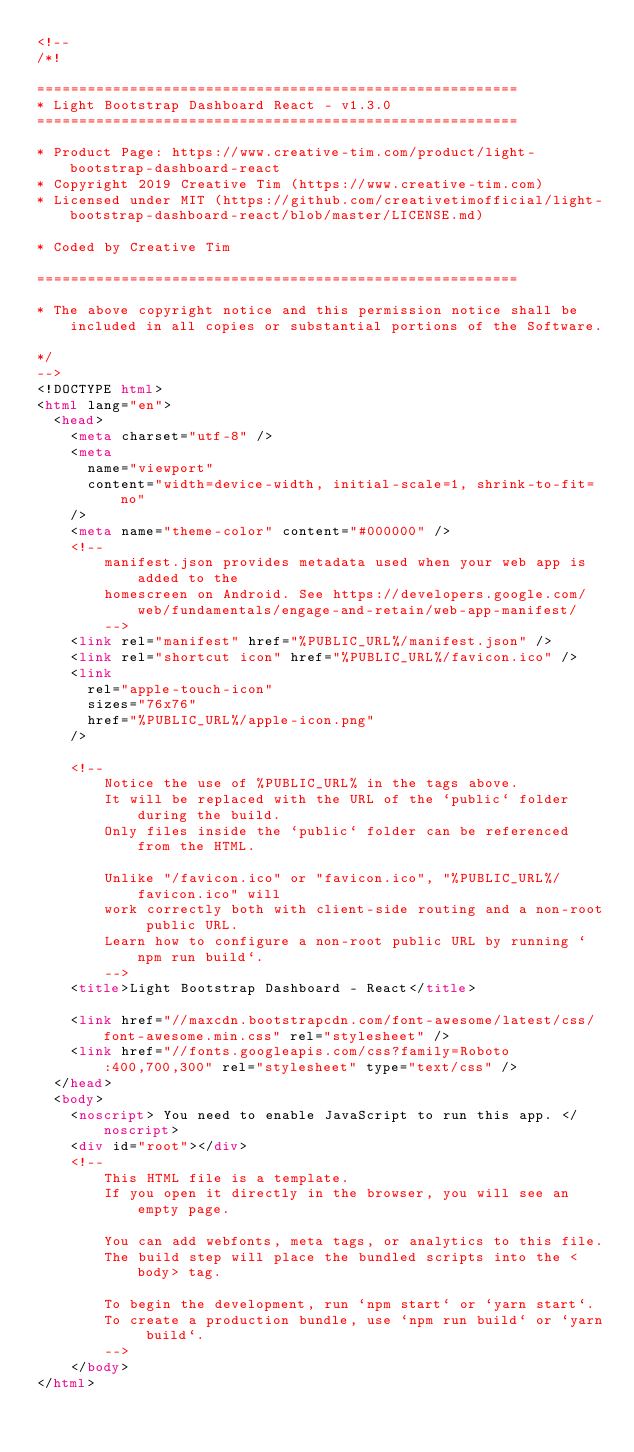Convert code to text. <code><loc_0><loc_0><loc_500><loc_500><_HTML_><!--
/*!

=========================================================
* Light Bootstrap Dashboard React - v1.3.0
=========================================================

* Product Page: https://www.creative-tim.com/product/light-bootstrap-dashboard-react
* Copyright 2019 Creative Tim (https://www.creative-tim.com)
* Licensed under MIT (https://github.com/creativetimofficial/light-bootstrap-dashboard-react/blob/master/LICENSE.md)

* Coded by Creative Tim

=========================================================

* The above copyright notice and this permission notice shall be included in all copies or substantial portions of the Software.

*/
-->
<!DOCTYPE html>
<html lang="en">
  <head>
    <meta charset="utf-8" />
    <meta
      name="viewport"
      content="width=device-width, initial-scale=1, shrink-to-fit=no"
    />
    <meta name="theme-color" content="#000000" />
    <!--
        manifest.json provides metadata used when your web app is added to the
        homescreen on Android. See https://developers.google.com/web/fundamentals/engage-and-retain/web-app-manifest/
        -->
    <link rel="manifest" href="%PUBLIC_URL%/manifest.json" />
    <link rel="shortcut icon" href="%PUBLIC_URL%/favicon.ico" />
    <link
      rel="apple-touch-icon"
      sizes="76x76"
      href="%PUBLIC_URL%/apple-icon.png"
    />

    <!--
        Notice the use of %PUBLIC_URL% in the tags above.
        It will be replaced with the URL of the `public` folder during the build.
        Only files inside the `public` folder can be referenced from the HTML.

        Unlike "/favicon.ico" or "favicon.ico", "%PUBLIC_URL%/favicon.ico" will
        work correctly both with client-side routing and a non-root public URL.
        Learn how to configure a non-root public URL by running `npm run build`.
        -->
    <title>Light Bootstrap Dashboard - React</title>

    <link href="//maxcdn.bootstrapcdn.com/font-awesome/latest/css/font-awesome.min.css" rel="stylesheet" />
    <link href="//fonts.googleapis.com/css?family=Roboto:400,700,300" rel="stylesheet" type="text/css" />
  </head>
  <body>
    <noscript> You need to enable JavaScript to run this app. </noscript>
    <div id="root"></div>
    <!--
        This HTML file is a template.
        If you open it directly in the browser, you will see an empty page.

        You can add webfonts, meta tags, or analytics to this file.
        The build step will place the bundled scripts into the <body> tag.

        To begin the development, run `npm start` or `yarn start`.
        To create a production bundle, use `npm run build` or `yarn build`.
        -->
    </body>
</html>
</code> 